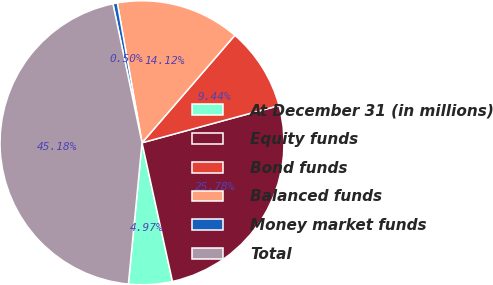Convert chart. <chart><loc_0><loc_0><loc_500><loc_500><pie_chart><fcel>At December 31 (in millions)<fcel>Equity funds<fcel>Bond funds<fcel>Balanced funds<fcel>Money market funds<fcel>Total<nl><fcel>4.97%<fcel>25.78%<fcel>9.44%<fcel>14.12%<fcel>0.5%<fcel>45.18%<nl></chart> 